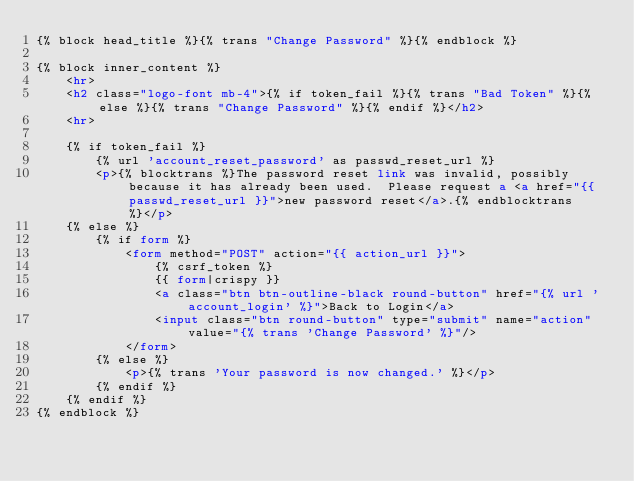<code> <loc_0><loc_0><loc_500><loc_500><_HTML_>{% block head_title %}{% trans "Change Password" %}{% endblock %}

{% block inner_content %}
    <hr>
    <h2 class="logo-font mb-4">{% if token_fail %}{% trans "Bad Token" %}{% else %}{% trans "Change Password" %}{% endif %}</h2>
    <hr>

    {% if token_fail %}
        {% url 'account_reset_password' as passwd_reset_url %}
        <p>{% blocktrans %}The password reset link was invalid, possibly because it has already been used.  Please request a <a href="{{ passwd_reset_url }}">new password reset</a>.{% endblocktrans %}</p>
    {% else %}
        {% if form %}
            <form method="POST" action="{{ action_url }}">
                {% csrf_token %}
                {{ form|crispy }}
                <a class="btn btn-outline-black round-button" href="{% url 'account_login' %}">Back to Login</a>
                <input class="btn round-button" type="submit" name="action" value="{% trans 'Change Password' %}"/>
            </form>
        {% else %}
            <p>{% trans 'Your password is now changed.' %}</p>
        {% endif %}
    {% endif %}
{% endblock %}
</code> 